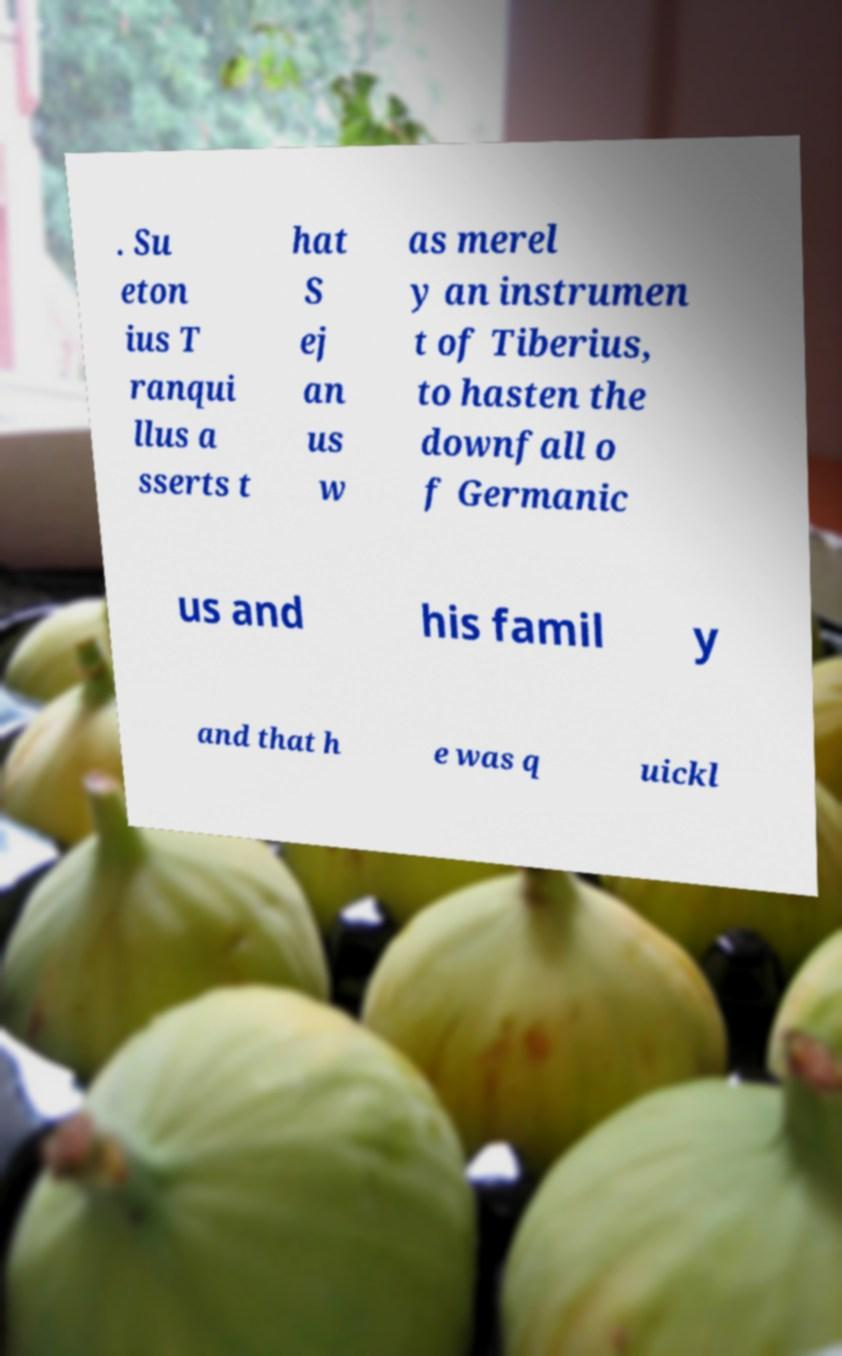What messages or text are displayed in this image? I need them in a readable, typed format. . Su eton ius T ranqui llus a sserts t hat S ej an us w as merel y an instrumen t of Tiberius, to hasten the downfall o f Germanic us and his famil y and that h e was q uickl 